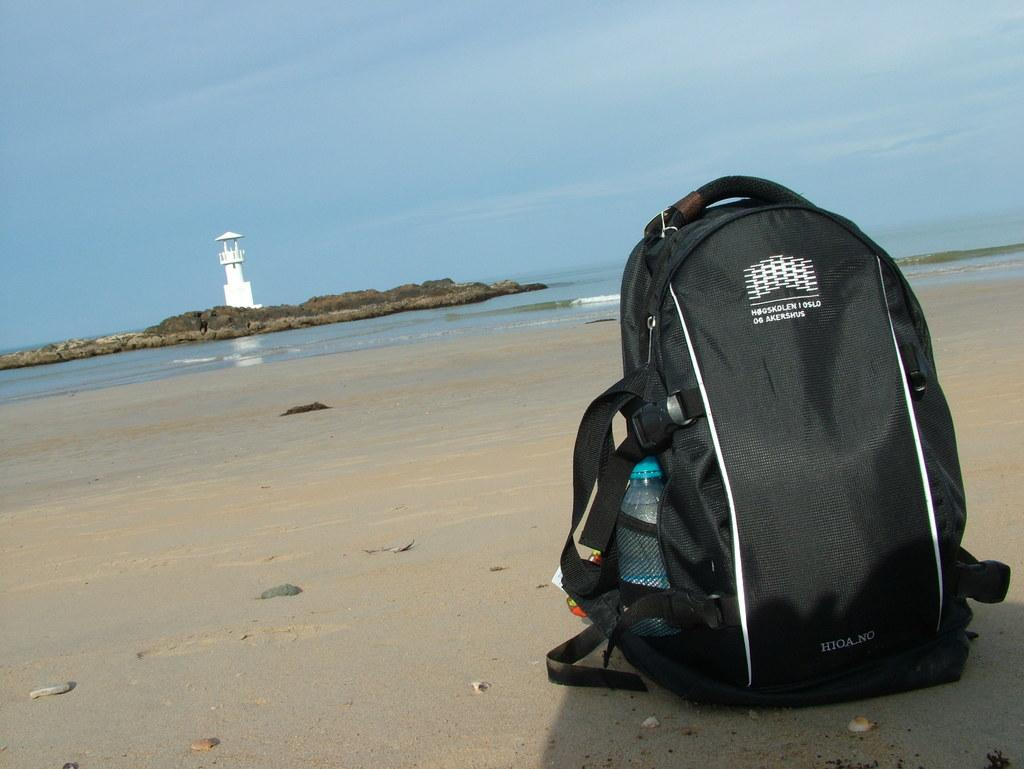<image>
Create a compact narrative representing the image presented. A HIOA NO backpack is sitting on a beach by a lighthouse. 